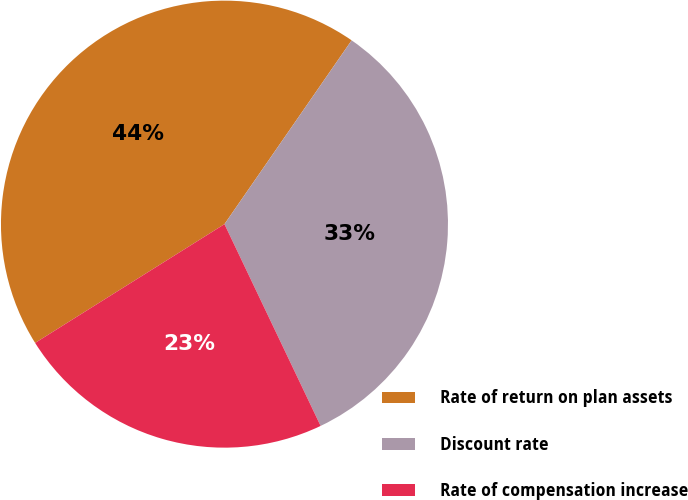Convert chart to OTSL. <chart><loc_0><loc_0><loc_500><loc_500><pie_chart><fcel>Rate of return on plan assets<fcel>Discount rate<fcel>Rate of compensation increase<nl><fcel>43.55%<fcel>33.29%<fcel>23.16%<nl></chart> 